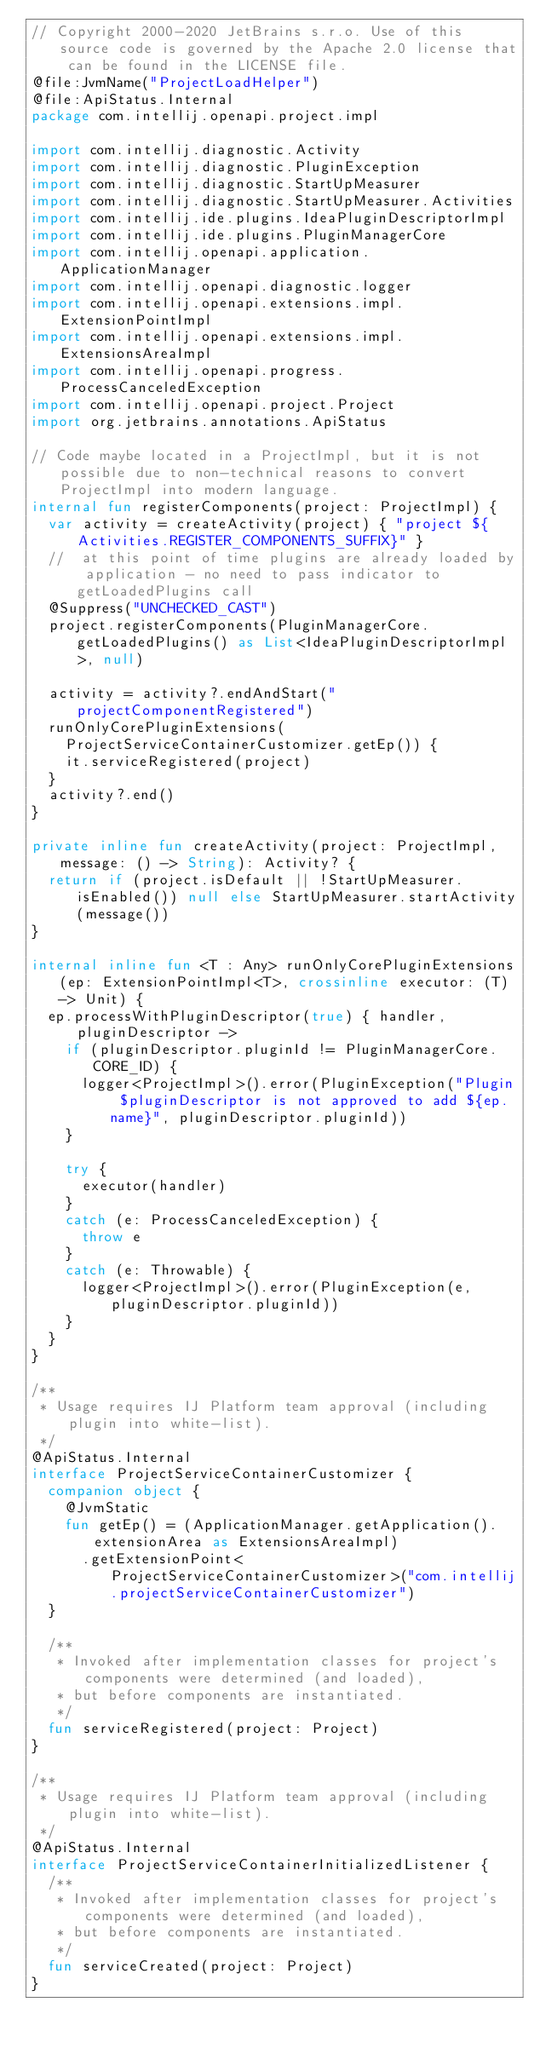Convert code to text. <code><loc_0><loc_0><loc_500><loc_500><_Kotlin_>// Copyright 2000-2020 JetBrains s.r.o. Use of this source code is governed by the Apache 2.0 license that can be found in the LICENSE file.
@file:JvmName("ProjectLoadHelper")
@file:ApiStatus.Internal
package com.intellij.openapi.project.impl

import com.intellij.diagnostic.Activity
import com.intellij.diagnostic.PluginException
import com.intellij.diagnostic.StartUpMeasurer
import com.intellij.diagnostic.StartUpMeasurer.Activities
import com.intellij.ide.plugins.IdeaPluginDescriptorImpl
import com.intellij.ide.plugins.PluginManagerCore
import com.intellij.openapi.application.ApplicationManager
import com.intellij.openapi.diagnostic.logger
import com.intellij.openapi.extensions.impl.ExtensionPointImpl
import com.intellij.openapi.extensions.impl.ExtensionsAreaImpl
import com.intellij.openapi.progress.ProcessCanceledException
import com.intellij.openapi.project.Project
import org.jetbrains.annotations.ApiStatus

// Code maybe located in a ProjectImpl, but it is not possible due to non-technical reasons to convert ProjectImpl into modern language.
internal fun registerComponents(project: ProjectImpl) {
  var activity = createActivity(project) { "project ${Activities.REGISTER_COMPONENTS_SUFFIX}" }
  //  at this point of time plugins are already loaded by application - no need to pass indicator to getLoadedPlugins call
  @Suppress("UNCHECKED_CAST")
  project.registerComponents(PluginManagerCore.getLoadedPlugins() as List<IdeaPluginDescriptorImpl>, null)

  activity = activity?.endAndStart("projectComponentRegistered")
  runOnlyCorePluginExtensions(
    ProjectServiceContainerCustomizer.getEp()) {
    it.serviceRegistered(project)
  }
  activity?.end()
}

private inline fun createActivity(project: ProjectImpl, message: () -> String): Activity? {
  return if (project.isDefault || !StartUpMeasurer.isEnabled()) null else StartUpMeasurer.startActivity(message())
}

internal inline fun <T : Any> runOnlyCorePluginExtensions(ep: ExtensionPointImpl<T>, crossinline executor: (T) -> Unit) {
  ep.processWithPluginDescriptor(true) { handler, pluginDescriptor ->
    if (pluginDescriptor.pluginId != PluginManagerCore.CORE_ID) {
      logger<ProjectImpl>().error(PluginException("Plugin $pluginDescriptor is not approved to add ${ep.name}", pluginDescriptor.pluginId))
    }

    try {
      executor(handler)
    }
    catch (e: ProcessCanceledException) {
      throw e
    }
    catch (e: Throwable) {
      logger<ProjectImpl>().error(PluginException(e, pluginDescriptor.pluginId))
    }
  }
}

/**
 * Usage requires IJ Platform team approval (including plugin into white-list).
 */
@ApiStatus.Internal
interface ProjectServiceContainerCustomizer {
  companion object {
    @JvmStatic
    fun getEp() = (ApplicationManager.getApplication().extensionArea as ExtensionsAreaImpl)
      .getExtensionPoint<ProjectServiceContainerCustomizer>("com.intellij.projectServiceContainerCustomizer")
  }

  /**
   * Invoked after implementation classes for project's components were determined (and loaded),
   * but before components are instantiated.
   */
  fun serviceRegistered(project: Project)
}

/**
 * Usage requires IJ Platform team approval (including plugin into white-list).
 */
@ApiStatus.Internal
interface ProjectServiceContainerInitializedListener {
  /**
   * Invoked after implementation classes for project's components were determined (and loaded),
   * but before components are instantiated.
   */
  fun serviceCreated(project: Project)
}</code> 